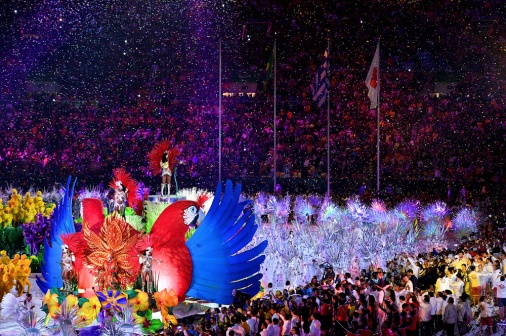How might the designs of the floats contribute to the overall theme of the event? The striking designs of the floats, resembling mythical birds, serve as the parade's visual anchors, contributing significantly to the event’s theme. These larger-than-life representations suggest a fusion of cultural myths with a celebration of nature's beauty and diversity. The fiery phoenix and the tranquil peacock could symbolize the duality of passion and serenity, invoking themes of rebirth, immortality, and beauty that are often celebrated in grand ceremonies. The intricate details, bold colors, and the scale of these floats make them the focal point around which the rest of the parade's elements revolve, elevating the event to an artistic masterpiece presided over by figures of legend and lore. 